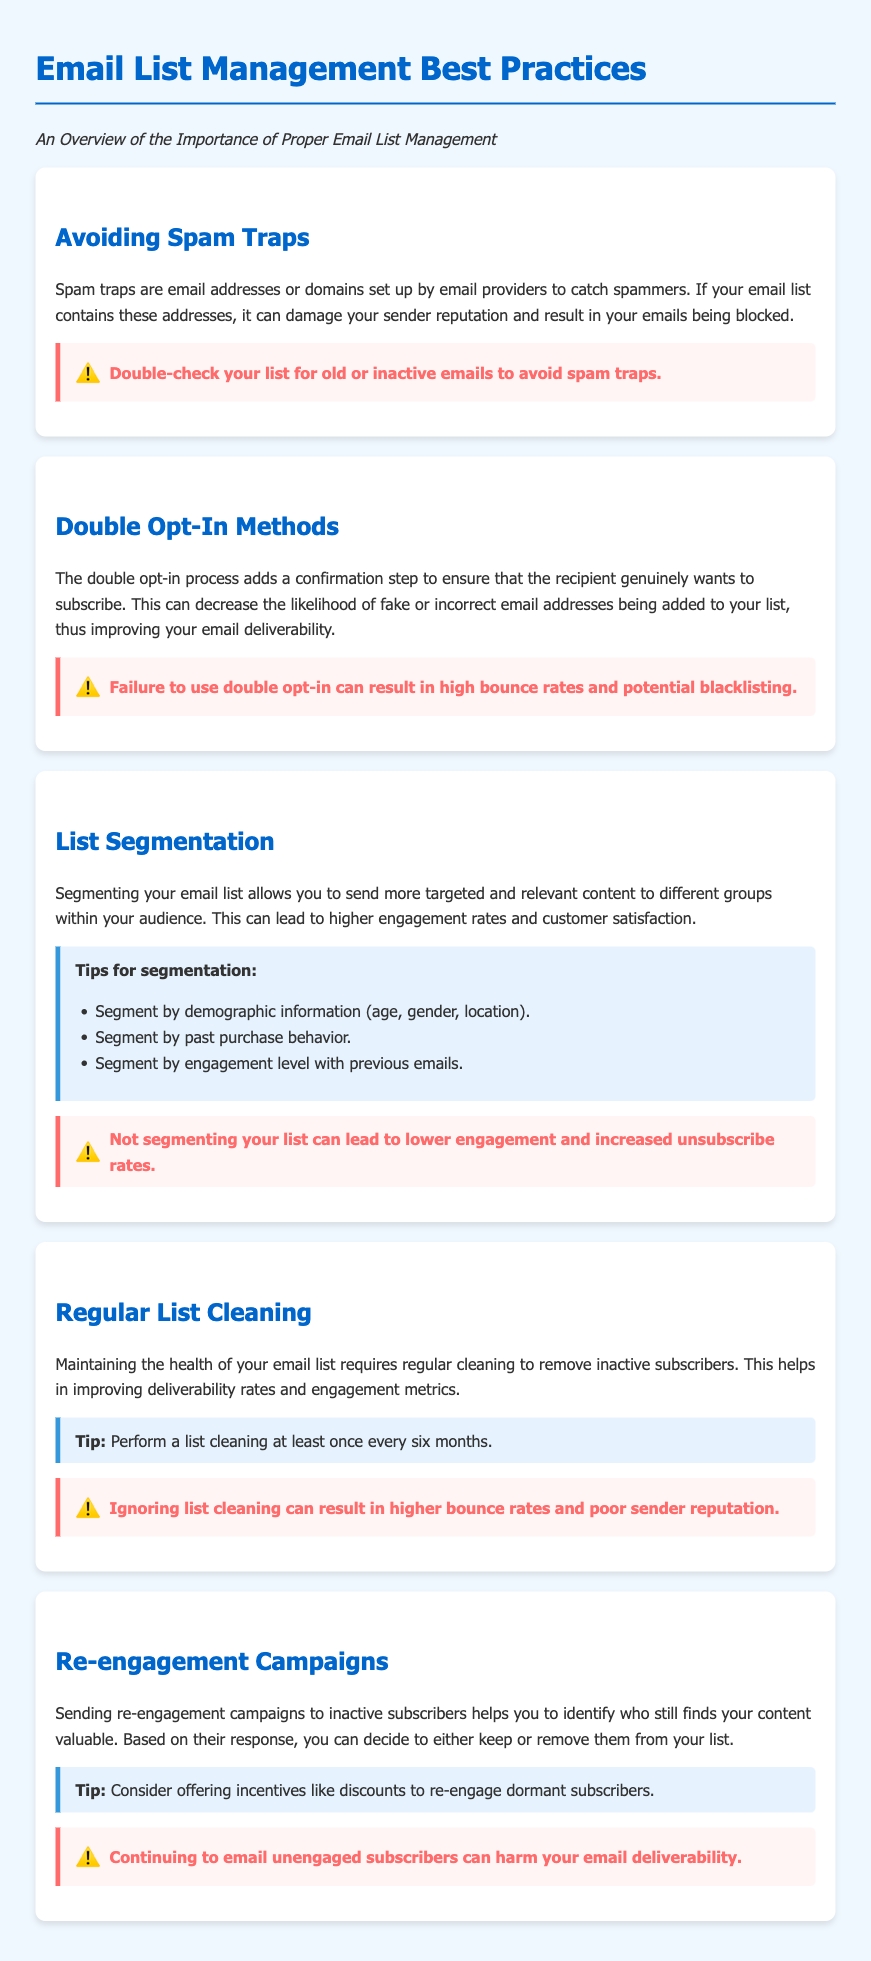What are spam traps? Spam traps are email addresses or domains set up by email providers to catch spammers.
Answer: Email addresses or domains What does the double opt-in process ensure? The double opt-in process adds a confirmation step to ensure that the recipient genuinely wants to subscribe.
Answer: Genuine subscription What can high bounce rates lead to? Failure to use double opt-in can result in high bounce rates and potential blacklisting.
Answer: Blacklisting What is a key aspect of list segmentation? Segmenting your email list allows you to send more targeted and relevant content to different groups within your audience.
Answer: Targeted content How often should you perform a list cleaning? Perform a list cleaning at least once every six months.
Answer: Once every six months What can ignoring list cleaning result in? Ignoring list cleaning can result in higher bounce rates and poor sender reputation.
Answer: Higher bounce rates What is a recommended action for inactive subscribers? Sending re-engagement campaigns to inactive subscribers helps you to identify who still finds your content valuable.
Answer: Re-engagement campaigns What is a suggested incentive for re-engagement? Consider offering incentives like discounts to re-engage dormant subscribers.
Answer: Discounts What will not segmenting your list lead to? Not segmenting your list can lead to lower engagement and increased unsubscribe rates.
Answer: Lower engagement 